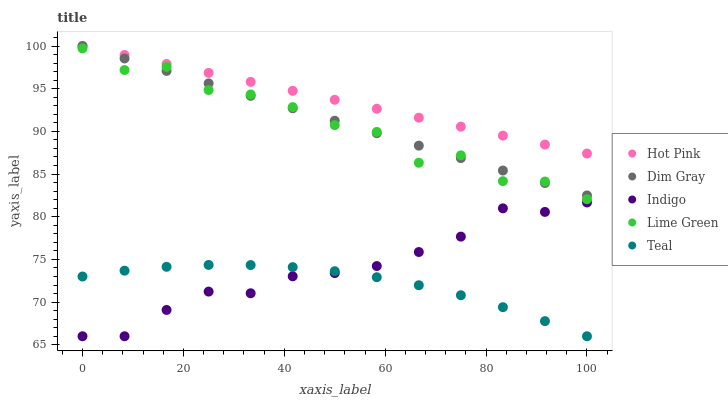Does Teal have the minimum area under the curve?
Answer yes or no. Yes. Does Hot Pink have the maximum area under the curve?
Answer yes or no. Yes. Does Dim Gray have the minimum area under the curve?
Answer yes or no. No. Does Dim Gray have the maximum area under the curve?
Answer yes or no. No. Is Hot Pink the smoothest?
Answer yes or no. Yes. Is Lime Green the roughest?
Answer yes or no. Yes. Is Dim Gray the smoothest?
Answer yes or no. No. Is Dim Gray the roughest?
Answer yes or no. No. Does Indigo have the lowest value?
Answer yes or no. Yes. Does Dim Gray have the lowest value?
Answer yes or no. No. Does Hot Pink have the highest value?
Answer yes or no. Yes. Does Indigo have the highest value?
Answer yes or no. No. Is Indigo less than Lime Green?
Answer yes or no. Yes. Is Dim Gray greater than Teal?
Answer yes or no. Yes. Does Dim Gray intersect Lime Green?
Answer yes or no. Yes. Is Dim Gray less than Lime Green?
Answer yes or no. No. Is Dim Gray greater than Lime Green?
Answer yes or no. No. Does Indigo intersect Lime Green?
Answer yes or no. No. 